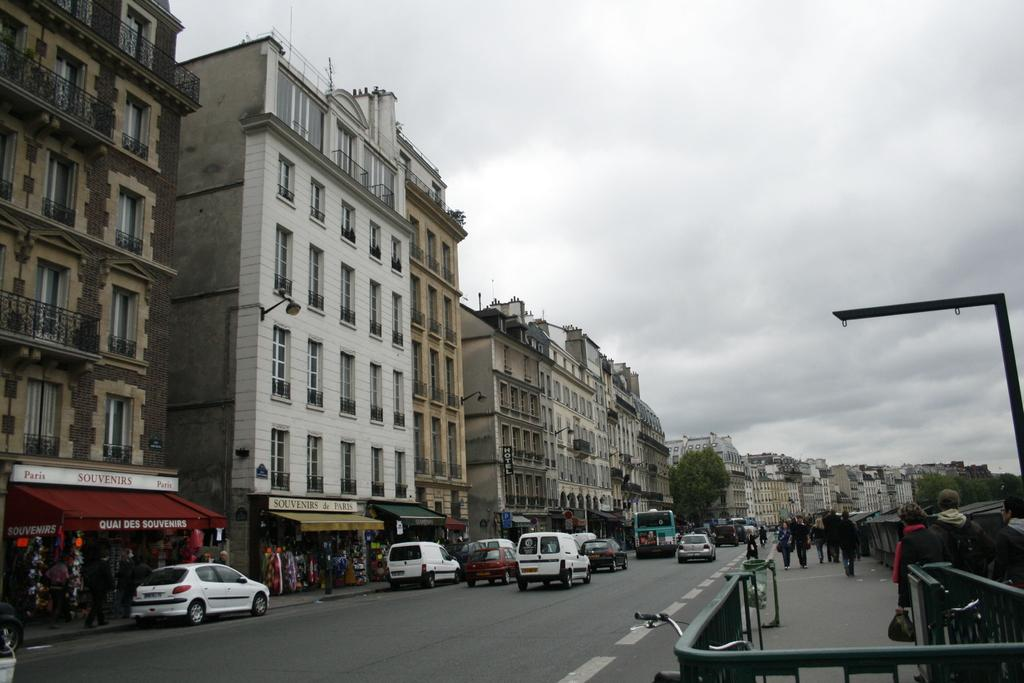What can be found in the left corner of the image? There are buildings, stores, and vehicles in the left corner of the image. What is the weather like in the image? The sky is cloudy in the image. Where are the people located in the image? The people are standing in the right corner of the image. What type of thrill can be seen in the image? There is no specific thrill depicted in the image; it features buildings, stores, vehicles, and people. Is there a discussion taking place in the image? There is no indication of a discussion taking place in the image. 